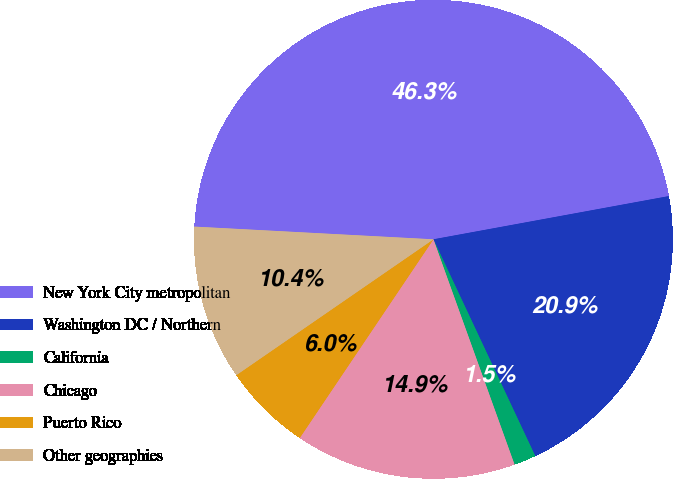Convert chart. <chart><loc_0><loc_0><loc_500><loc_500><pie_chart><fcel>New York City metropolitan<fcel>Washington DC / Northern<fcel>California<fcel>Chicago<fcel>Puerto Rico<fcel>Other geographies<nl><fcel>46.27%<fcel>20.9%<fcel>1.49%<fcel>14.93%<fcel>5.97%<fcel>10.45%<nl></chart> 